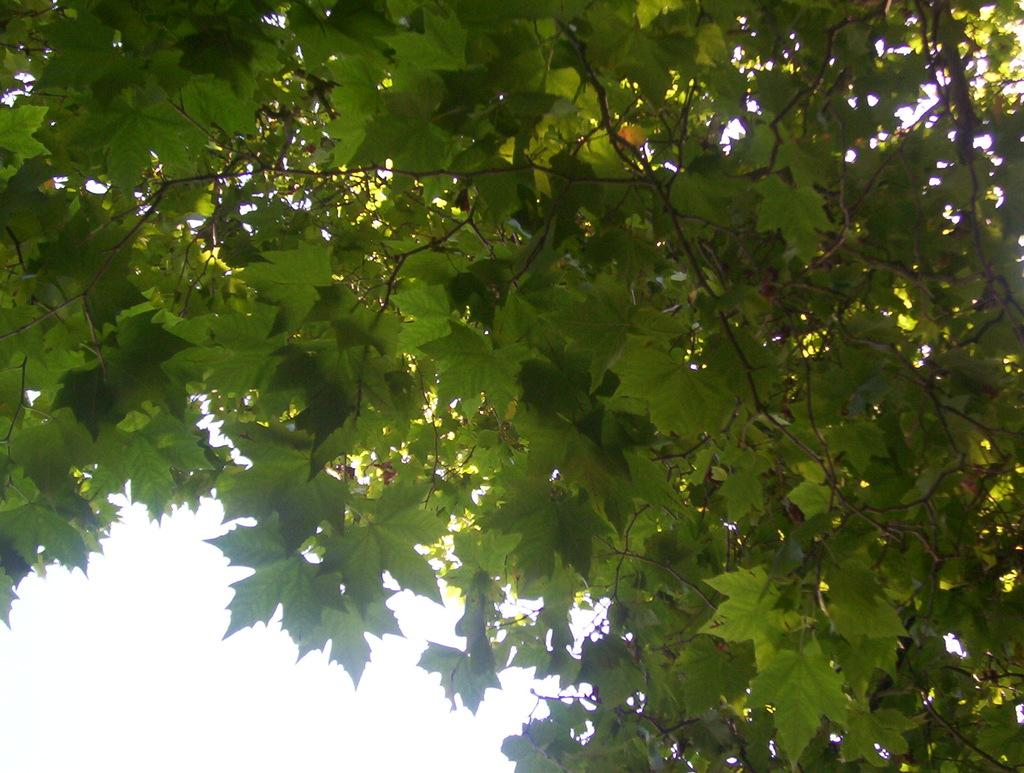What type of plant can be seen in the image? There is a tree in the image. What are the visible features of the tree? The tree has leaves and stems. What type of blood vessels can be seen in the tree in the image? There is no mention of blood vessels or any biological processes in the image; it simply shows a tree with leaves and stems. 